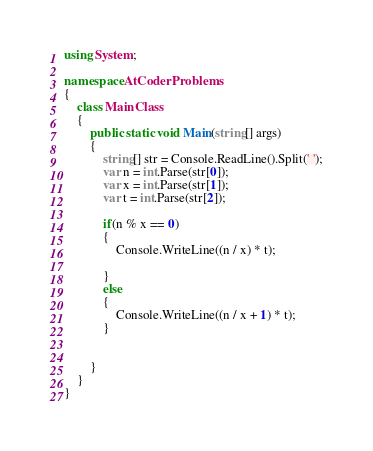<code> <loc_0><loc_0><loc_500><loc_500><_C#_>using System;

namespace AtCoderProblems
{
    class MainClass
    {
        public static void Main(string[] args)
        {
            string[] str = Console.ReadLine().Split(' ');
            var n = int.Parse(str[0]);
            var x = int.Parse(str[1]);
            var t = int.Parse(str[2]);

            if(n % x == 0)
            {
                Console.WriteLine((n / x) * t);

            }
            else
            {
                Console.WriteLine((n / x + 1) * t);
            }

            
        }
    }
}
</code> 